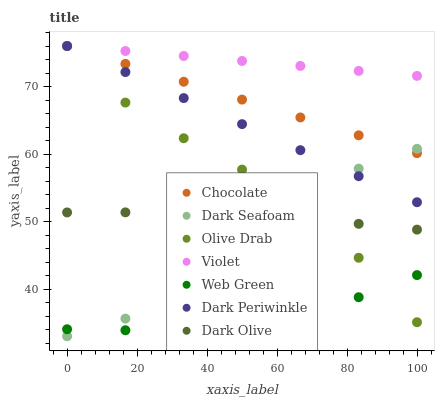Does Web Green have the minimum area under the curve?
Answer yes or no. Yes. Does Violet have the maximum area under the curve?
Answer yes or no. Yes. Does Chocolate have the minimum area under the curve?
Answer yes or no. No. Does Chocolate have the maximum area under the curve?
Answer yes or no. No. Is Chocolate the smoothest?
Answer yes or no. Yes. Is Dark Seafoam the roughest?
Answer yes or no. Yes. Is Web Green the smoothest?
Answer yes or no. No. Is Web Green the roughest?
Answer yes or no. No. Does Dark Seafoam have the lowest value?
Answer yes or no. Yes. Does Web Green have the lowest value?
Answer yes or no. No. Does Olive Drab have the highest value?
Answer yes or no. Yes. Does Web Green have the highest value?
Answer yes or no. No. Is Web Green less than Dark Periwinkle?
Answer yes or no. Yes. Is Chocolate greater than Dark Olive?
Answer yes or no. Yes. Does Violet intersect Chocolate?
Answer yes or no. Yes. Is Violet less than Chocolate?
Answer yes or no. No. Is Violet greater than Chocolate?
Answer yes or no. No. Does Web Green intersect Dark Periwinkle?
Answer yes or no. No. 